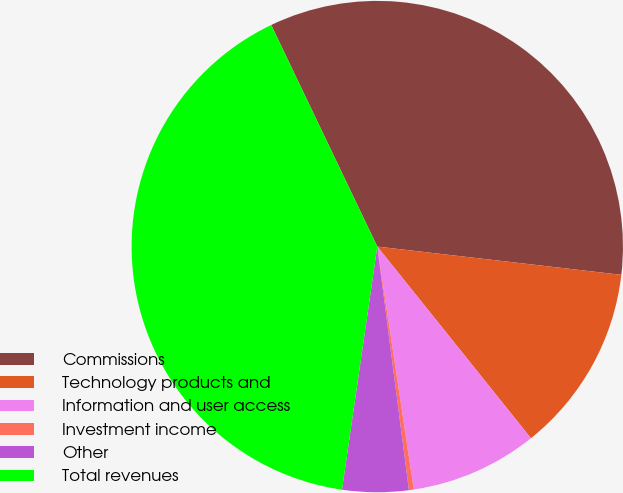Convert chart. <chart><loc_0><loc_0><loc_500><loc_500><pie_chart><fcel>Commissions<fcel>Technology products and<fcel>Information and user access<fcel>Investment income<fcel>Other<fcel>Total revenues<nl><fcel>33.94%<fcel>12.41%<fcel>8.38%<fcel>0.32%<fcel>4.35%<fcel>40.6%<nl></chart> 